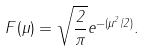<formula> <loc_0><loc_0><loc_500><loc_500>F ( \mu ) = \sqrt { \frac { 2 } { \pi } } e ^ { - ( \mu ^ { 2 } / 2 ) } .</formula> 